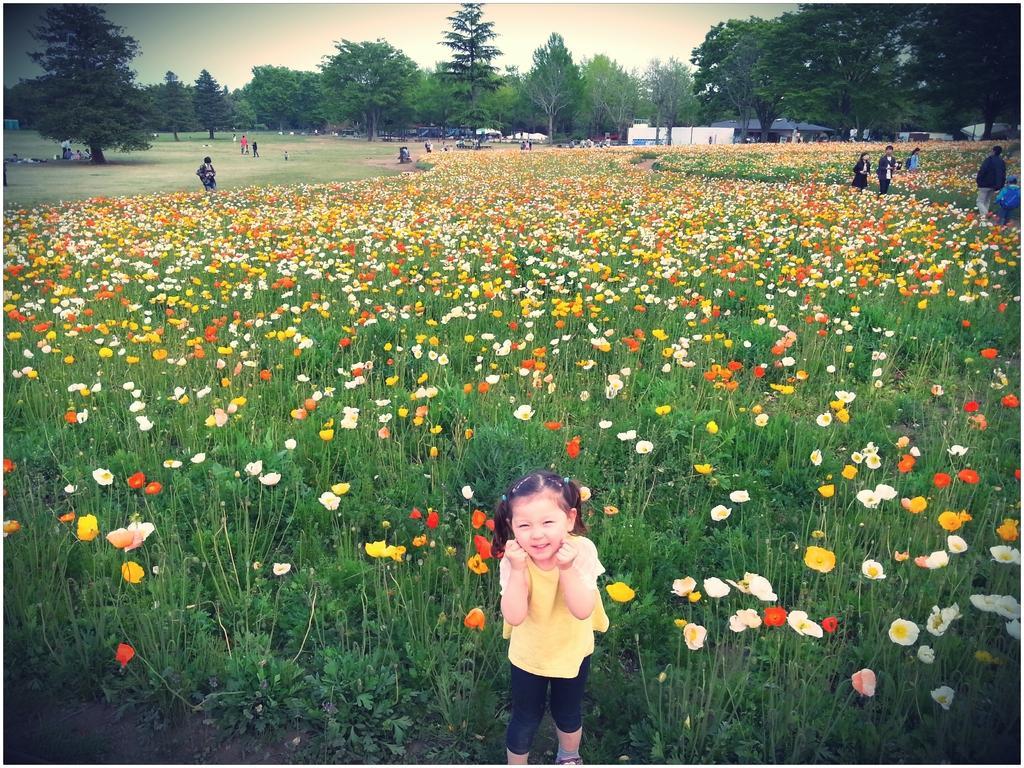How would you summarize this image in a sentence or two? At the bottom there is a girl standing, she wore yellow color top. There are flower plants in this image and at the back side there are trees and houses. On the right side few persons are walking through these plants. 